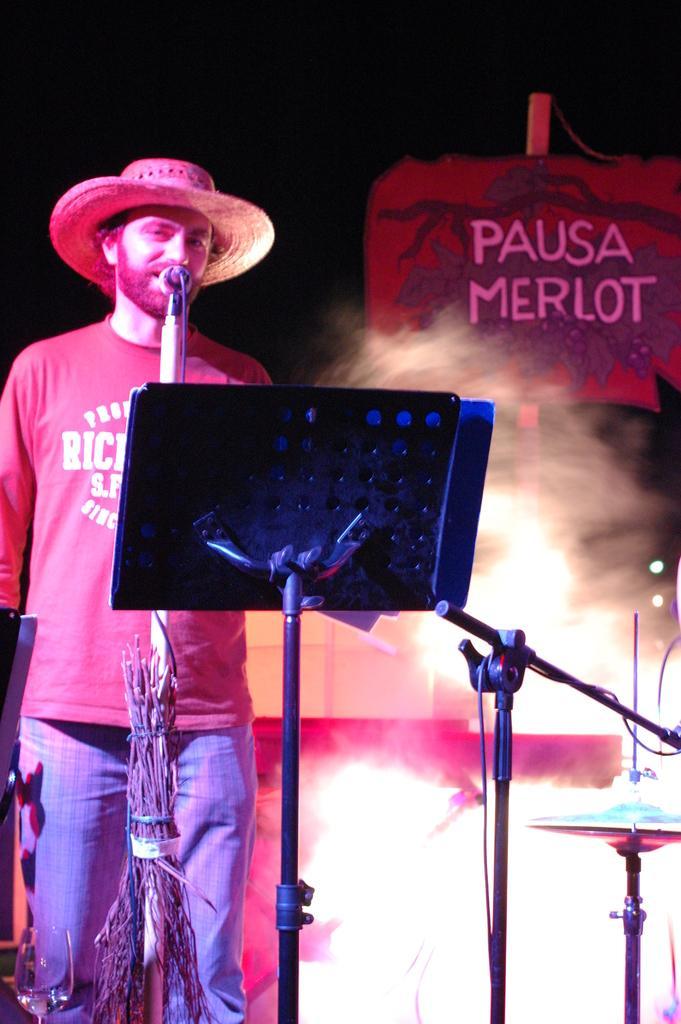Could you give a brief overview of what you see in this image? In this picture I can see a man standing and singing with the help of a microphone and he wore a cap on his head and i can see a book stand and drums on the side and I can see a board with text and smoke. 